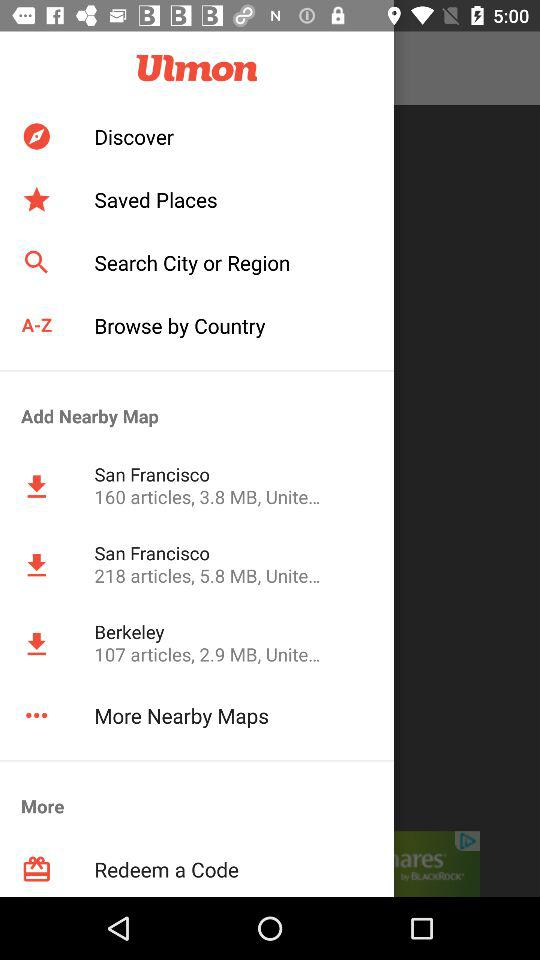How do I redeem a code?
When the provided information is insufficient, respond with <no answer>. <no answer> 